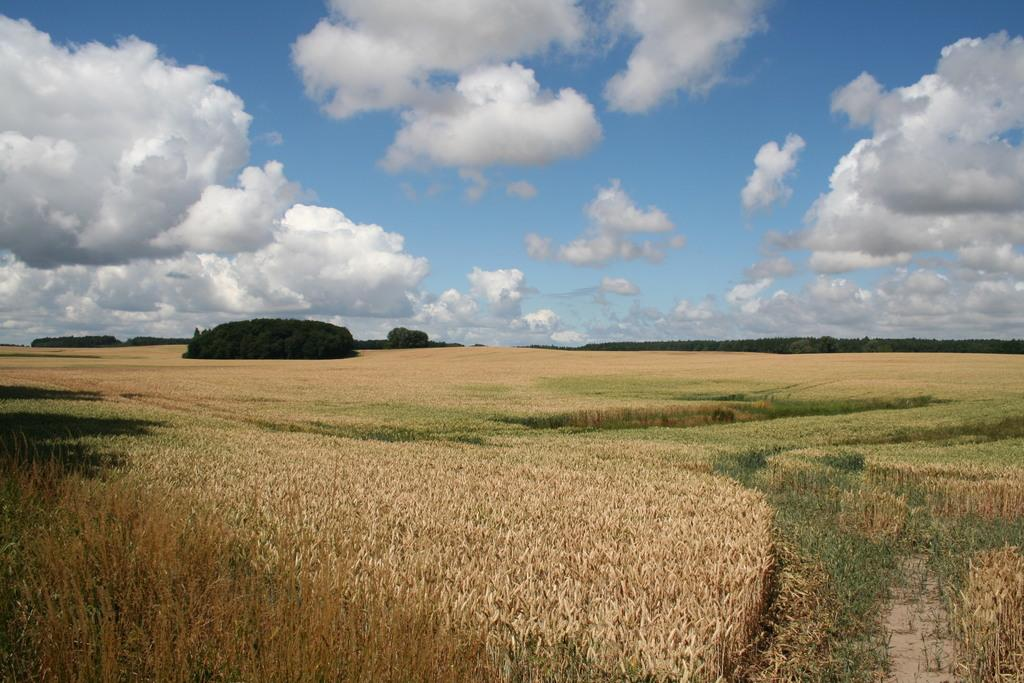What type of landscape is shown in the image? There is a paddy field in the image. Where is the paddy field located? The paddy field is on the land. What can be seen in the background of the image? There are trees in the background of the image. What is visible in the sky in the image? The sky is visible in the image, and clouds are present. What type of paper is being discussed by the committee in the image? There is no committee or paper present in the image; it features a paddy field, trees, and a sky with clouds. 